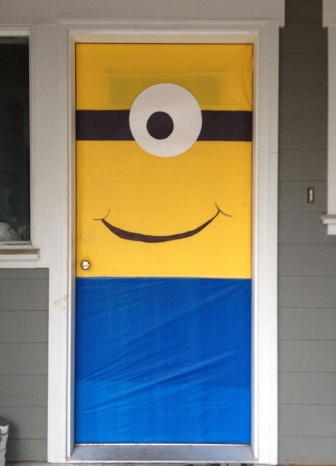What would be a realistic scenario where this door fits perfectly? A realistic scenario for this creatively decorated door would be in a daycare center or a children's playroom. The lively minion poster would captivate the children's attention, sparking excitement and joy as they enter. The fun and whimsical design sets a welcoming tone, making it a perfect fit for a space dedicated to children and their imaginative activities.  Give me another realistic scenario. Another realistic scenario could be during a themed birthday party at home. The decorated door serves as a grand entrance to the party venue, making children eager to step inside and join the festivities. The minion theme could be carried throughout with additional decorations, costumes, and games, creating a cohesive and exciting atmosphere for the celebration. 